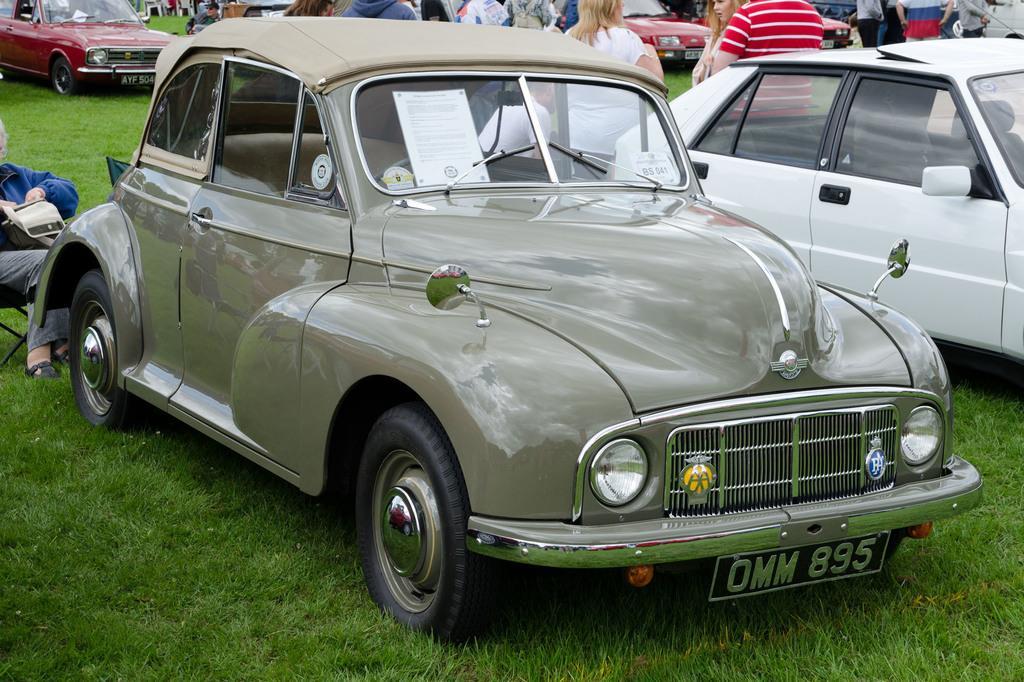Could you give a brief overview of what you see in this image? In this image we can see a few people, one of them is sitting on the chair, there are cars, also we can see the grass. 